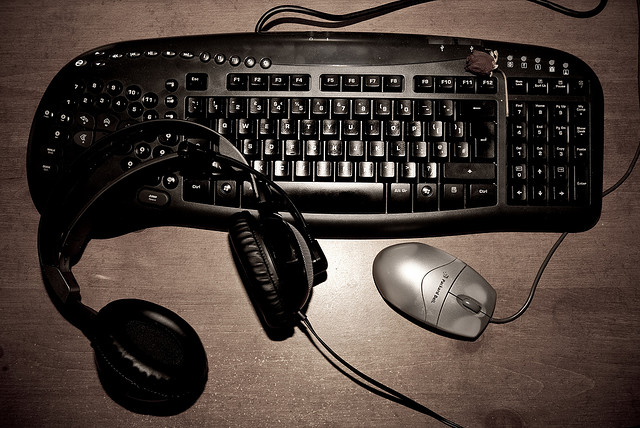<image>What brand is the mouse? It is ambiguous to determine the brand of the mouse. It could be gateway, logitech, microsoft or panasonic. What brand is the mouse? I don't know what brand the mouse is. It could be Gateway, Logitech, Microsoft, or Panasonic. 